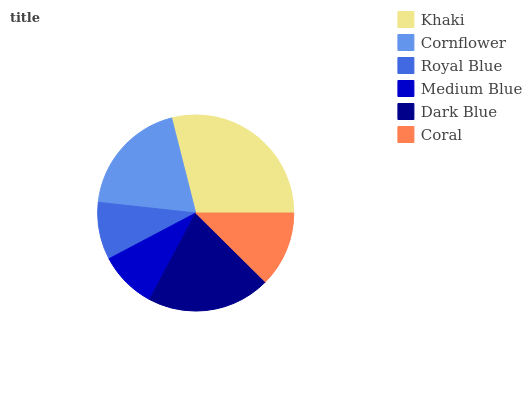Is Royal Blue the minimum?
Answer yes or no. Yes. Is Khaki the maximum?
Answer yes or no. Yes. Is Cornflower the minimum?
Answer yes or no. No. Is Cornflower the maximum?
Answer yes or no. No. Is Khaki greater than Cornflower?
Answer yes or no. Yes. Is Cornflower less than Khaki?
Answer yes or no. Yes. Is Cornflower greater than Khaki?
Answer yes or no. No. Is Khaki less than Cornflower?
Answer yes or no. No. Is Cornflower the high median?
Answer yes or no. Yes. Is Coral the low median?
Answer yes or no. Yes. Is Royal Blue the high median?
Answer yes or no. No. Is Khaki the low median?
Answer yes or no. No. 